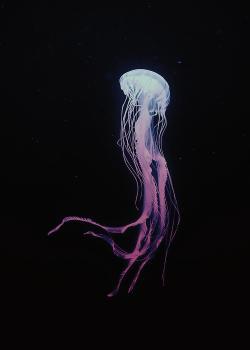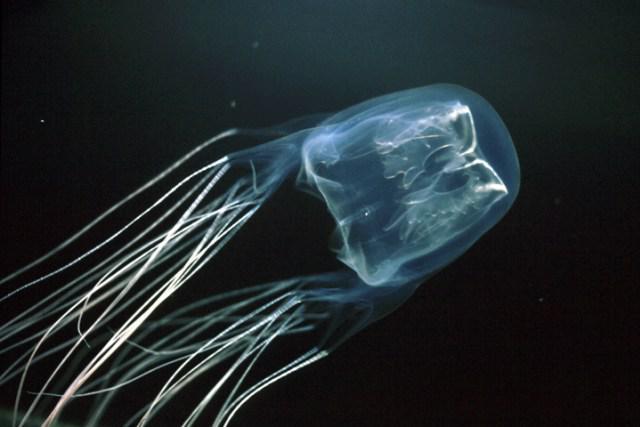The first image is the image on the left, the second image is the image on the right. Examine the images to the left and right. Is the description "Two jellyfish, one in each image, have similar body shape and color and long thread-like tendrills, but the tendrills are flowing back in differing directions." accurate? Answer yes or no. No. The first image is the image on the left, the second image is the image on the right. Given the left and right images, does the statement "Each image shows a jellyfish with only long string-like tentacles trailing from a gumdrop-shaped body." hold true? Answer yes or no. No. 